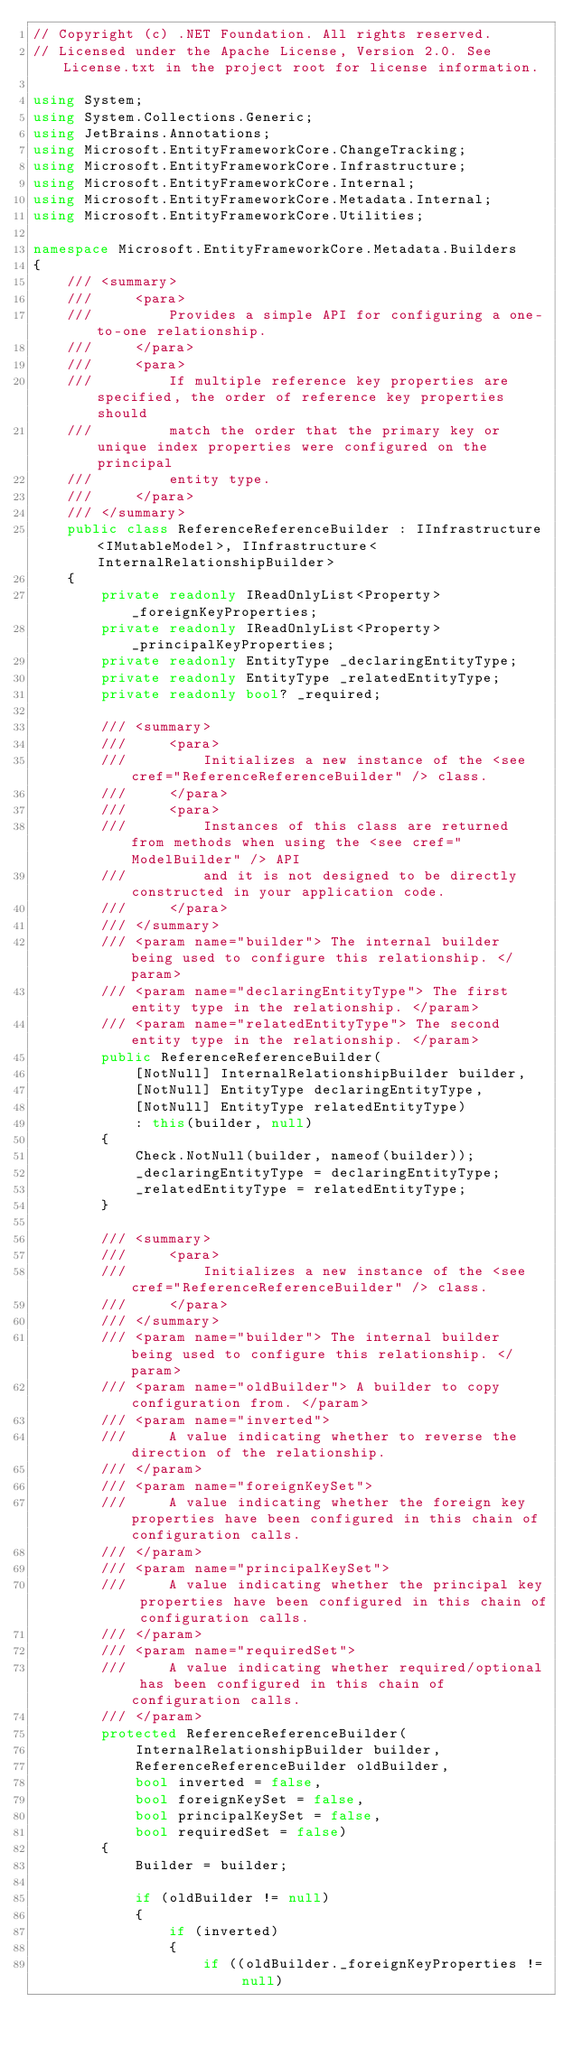Convert code to text. <code><loc_0><loc_0><loc_500><loc_500><_C#_>// Copyright (c) .NET Foundation. All rights reserved.
// Licensed under the Apache License, Version 2.0. See License.txt in the project root for license information.

using System;
using System.Collections.Generic;
using JetBrains.Annotations;
using Microsoft.EntityFrameworkCore.ChangeTracking;
using Microsoft.EntityFrameworkCore.Infrastructure;
using Microsoft.EntityFrameworkCore.Internal;
using Microsoft.EntityFrameworkCore.Metadata.Internal;
using Microsoft.EntityFrameworkCore.Utilities;

namespace Microsoft.EntityFrameworkCore.Metadata.Builders
{
    /// <summary>
    ///     <para>
    ///         Provides a simple API for configuring a one-to-one relationship.
    ///     </para>
    ///     <para>
    ///         If multiple reference key properties are specified, the order of reference key properties should
    ///         match the order that the primary key or unique index properties were configured on the principal
    ///         entity type.
    ///     </para>
    /// </summary>
    public class ReferenceReferenceBuilder : IInfrastructure<IMutableModel>, IInfrastructure<InternalRelationshipBuilder>
    {
        private readonly IReadOnlyList<Property> _foreignKeyProperties;
        private readonly IReadOnlyList<Property> _principalKeyProperties;
        private readonly EntityType _declaringEntityType;
        private readonly EntityType _relatedEntityType;
        private readonly bool? _required;

        /// <summary>
        ///     <para>
        ///         Initializes a new instance of the <see cref="ReferenceReferenceBuilder" /> class.
        ///     </para>
        ///     <para>
        ///         Instances of this class are returned from methods when using the <see cref="ModelBuilder" /> API
        ///         and it is not designed to be directly constructed in your application code.
        ///     </para>
        /// </summary>
        /// <param name="builder"> The internal builder being used to configure this relationship. </param>
        /// <param name="declaringEntityType"> The first entity type in the relationship. </param>
        /// <param name="relatedEntityType"> The second entity type in the relationship. </param>
        public ReferenceReferenceBuilder(
            [NotNull] InternalRelationshipBuilder builder,
            [NotNull] EntityType declaringEntityType,
            [NotNull] EntityType relatedEntityType)
            : this(builder, null)
        {
            Check.NotNull(builder, nameof(builder));
            _declaringEntityType = declaringEntityType;
            _relatedEntityType = relatedEntityType;
        }

        /// <summary>
        ///     <para>
        ///         Initializes a new instance of the <see cref="ReferenceReferenceBuilder" /> class.
        ///     </para>
        /// </summary>
        /// <param name="builder"> The internal builder being used to configure this relationship. </param>
        /// <param name="oldBuilder"> A builder to copy configuration from. </param>
        /// <param name="inverted">
        ///     A value indicating whether to reverse the direction of the relationship.
        /// </param>
        /// <param name="foreignKeySet">
        ///     A value indicating whether the foreign key properties have been configured in this chain of configuration calls.
        /// </param>
        /// <param name="principalKeySet">
        ///     A value indicating whether the principal key properties have been configured in this chain of configuration calls.
        /// </param>
        /// <param name="requiredSet">
        ///     A value indicating whether required/optional has been configured in this chain of configuration calls.
        /// </param>
        protected ReferenceReferenceBuilder(
            InternalRelationshipBuilder builder,
            ReferenceReferenceBuilder oldBuilder,
            bool inverted = false,
            bool foreignKeySet = false,
            bool principalKeySet = false,
            bool requiredSet = false)
        {
            Builder = builder;

            if (oldBuilder != null)
            {
                if (inverted)
                {
                    if ((oldBuilder._foreignKeyProperties != null)</code> 